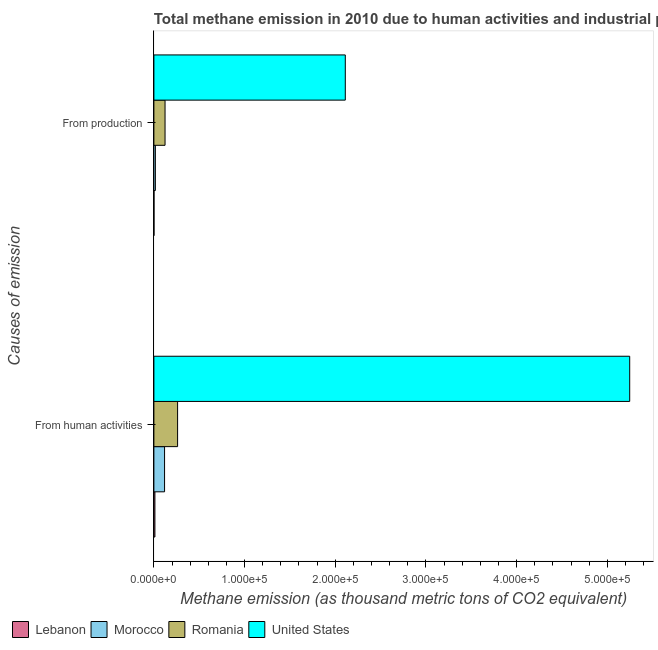Are the number of bars per tick equal to the number of legend labels?
Provide a short and direct response. Yes. How many bars are there on the 2nd tick from the bottom?
Your response must be concise. 4. What is the label of the 2nd group of bars from the top?
Keep it short and to the point. From human activities. What is the amount of emissions generated from industries in Morocco?
Make the answer very short. 1641.9. Across all countries, what is the maximum amount of emissions from human activities?
Your response must be concise. 5.25e+05. Across all countries, what is the minimum amount of emissions generated from industries?
Offer a very short reply. 118.4. In which country was the amount of emissions generated from industries minimum?
Make the answer very short. Lebanon. What is the total amount of emissions generated from industries in the graph?
Keep it short and to the point. 2.25e+05. What is the difference between the amount of emissions generated from industries in United States and that in Romania?
Keep it short and to the point. 1.99e+05. What is the difference between the amount of emissions from human activities in Lebanon and the amount of emissions generated from industries in United States?
Keep it short and to the point. -2.10e+05. What is the average amount of emissions generated from industries per country?
Give a very brief answer. 5.63e+04. What is the difference between the amount of emissions from human activities and amount of emissions generated from industries in Lebanon?
Provide a succinct answer. 1009. What is the ratio of the amount of emissions generated from industries in Romania to that in Morocco?
Your answer should be compact. 7.5. In how many countries, is the amount of emissions generated from industries greater than the average amount of emissions generated from industries taken over all countries?
Keep it short and to the point. 1. What does the 2nd bar from the top in From human activities represents?
Give a very brief answer. Romania. What does the 1st bar from the bottom in From human activities represents?
Make the answer very short. Lebanon. How many countries are there in the graph?
Make the answer very short. 4. What is the difference between two consecutive major ticks on the X-axis?
Provide a short and direct response. 1.00e+05. Are the values on the major ticks of X-axis written in scientific E-notation?
Give a very brief answer. Yes. Does the graph contain grids?
Offer a terse response. No. Where does the legend appear in the graph?
Your response must be concise. Bottom left. How many legend labels are there?
Your response must be concise. 4. What is the title of the graph?
Your answer should be compact. Total methane emission in 2010 due to human activities and industrial production. What is the label or title of the X-axis?
Your answer should be very brief. Methane emission (as thousand metric tons of CO2 equivalent). What is the label or title of the Y-axis?
Keep it short and to the point. Causes of emission. What is the Methane emission (as thousand metric tons of CO2 equivalent) of Lebanon in From human activities?
Your answer should be very brief. 1127.4. What is the Methane emission (as thousand metric tons of CO2 equivalent) in Morocco in From human activities?
Keep it short and to the point. 1.18e+04. What is the Methane emission (as thousand metric tons of CO2 equivalent) of Romania in From human activities?
Your answer should be compact. 2.61e+04. What is the Methane emission (as thousand metric tons of CO2 equivalent) of United States in From human activities?
Keep it short and to the point. 5.25e+05. What is the Methane emission (as thousand metric tons of CO2 equivalent) in Lebanon in From production?
Provide a short and direct response. 118.4. What is the Methane emission (as thousand metric tons of CO2 equivalent) in Morocco in From production?
Your answer should be very brief. 1641.9. What is the Methane emission (as thousand metric tons of CO2 equivalent) in Romania in From production?
Ensure brevity in your answer.  1.23e+04. What is the Methane emission (as thousand metric tons of CO2 equivalent) in United States in From production?
Your answer should be compact. 2.11e+05. Across all Causes of emission, what is the maximum Methane emission (as thousand metric tons of CO2 equivalent) of Lebanon?
Provide a succinct answer. 1127.4. Across all Causes of emission, what is the maximum Methane emission (as thousand metric tons of CO2 equivalent) in Morocco?
Offer a very short reply. 1.18e+04. Across all Causes of emission, what is the maximum Methane emission (as thousand metric tons of CO2 equivalent) of Romania?
Your response must be concise. 2.61e+04. Across all Causes of emission, what is the maximum Methane emission (as thousand metric tons of CO2 equivalent) in United States?
Make the answer very short. 5.25e+05. Across all Causes of emission, what is the minimum Methane emission (as thousand metric tons of CO2 equivalent) of Lebanon?
Your answer should be compact. 118.4. Across all Causes of emission, what is the minimum Methane emission (as thousand metric tons of CO2 equivalent) in Morocco?
Ensure brevity in your answer.  1641.9. Across all Causes of emission, what is the minimum Methane emission (as thousand metric tons of CO2 equivalent) of Romania?
Make the answer very short. 1.23e+04. Across all Causes of emission, what is the minimum Methane emission (as thousand metric tons of CO2 equivalent) of United States?
Your response must be concise. 2.11e+05. What is the total Methane emission (as thousand metric tons of CO2 equivalent) of Lebanon in the graph?
Your answer should be very brief. 1245.8. What is the total Methane emission (as thousand metric tons of CO2 equivalent) of Morocco in the graph?
Your response must be concise. 1.34e+04. What is the total Methane emission (as thousand metric tons of CO2 equivalent) in Romania in the graph?
Provide a succinct answer. 3.85e+04. What is the total Methane emission (as thousand metric tons of CO2 equivalent) of United States in the graph?
Keep it short and to the point. 7.36e+05. What is the difference between the Methane emission (as thousand metric tons of CO2 equivalent) in Lebanon in From human activities and that in From production?
Offer a terse response. 1009. What is the difference between the Methane emission (as thousand metric tons of CO2 equivalent) in Morocco in From human activities and that in From production?
Make the answer very short. 1.01e+04. What is the difference between the Methane emission (as thousand metric tons of CO2 equivalent) in Romania in From human activities and that in From production?
Your answer should be very brief. 1.38e+04. What is the difference between the Methane emission (as thousand metric tons of CO2 equivalent) of United States in From human activities and that in From production?
Your answer should be very brief. 3.14e+05. What is the difference between the Methane emission (as thousand metric tons of CO2 equivalent) in Lebanon in From human activities and the Methane emission (as thousand metric tons of CO2 equivalent) in Morocco in From production?
Ensure brevity in your answer.  -514.5. What is the difference between the Methane emission (as thousand metric tons of CO2 equivalent) of Lebanon in From human activities and the Methane emission (as thousand metric tons of CO2 equivalent) of Romania in From production?
Make the answer very short. -1.12e+04. What is the difference between the Methane emission (as thousand metric tons of CO2 equivalent) in Lebanon in From human activities and the Methane emission (as thousand metric tons of CO2 equivalent) in United States in From production?
Keep it short and to the point. -2.10e+05. What is the difference between the Methane emission (as thousand metric tons of CO2 equivalent) of Morocco in From human activities and the Methane emission (as thousand metric tons of CO2 equivalent) of Romania in From production?
Your answer should be compact. -538. What is the difference between the Methane emission (as thousand metric tons of CO2 equivalent) in Morocco in From human activities and the Methane emission (as thousand metric tons of CO2 equivalent) in United States in From production?
Make the answer very short. -1.99e+05. What is the difference between the Methane emission (as thousand metric tons of CO2 equivalent) of Romania in From human activities and the Methane emission (as thousand metric tons of CO2 equivalent) of United States in From production?
Give a very brief answer. -1.85e+05. What is the average Methane emission (as thousand metric tons of CO2 equivalent) in Lebanon per Causes of emission?
Your answer should be very brief. 622.9. What is the average Methane emission (as thousand metric tons of CO2 equivalent) of Morocco per Causes of emission?
Offer a very short reply. 6709.75. What is the average Methane emission (as thousand metric tons of CO2 equivalent) of Romania per Causes of emission?
Offer a very short reply. 1.92e+04. What is the average Methane emission (as thousand metric tons of CO2 equivalent) of United States per Causes of emission?
Give a very brief answer. 3.68e+05. What is the difference between the Methane emission (as thousand metric tons of CO2 equivalent) of Lebanon and Methane emission (as thousand metric tons of CO2 equivalent) of Morocco in From human activities?
Make the answer very short. -1.07e+04. What is the difference between the Methane emission (as thousand metric tons of CO2 equivalent) in Lebanon and Methane emission (as thousand metric tons of CO2 equivalent) in Romania in From human activities?
Keep it short and to the point. -2.50e+04. What is the difference between the Methane emission (as thousand metric tons of CO2 equivalent) of Lebanon and Methane emission (as thousand metric tons of CO2 equivalent) of United States in From human activities?
Your answer should be compact. -5.24e+05. What is the difference between the Methane emission (as thousand metric tons of CO2 equivalent) in Morocco and Methane emission (as thousand metric tons of CO2 equivalent) in Romania in From human activities?
Ensure brevity in your answer.  -1.44e+04. What is the difference between the Methane emission (as thousand metric tons of CO2 equivalent) in Morocco and Methane emission (as thousand metric tons of CO2 equivalent) in United States in From human activities?
Offer a very short reply. -5.13e+05. What is the difference between the Methane emission (as thousand metric tons of CO2 equivalent) of Romania and Methane emission (as thousand metric tons of CO2 equivalent) of United States in From human activities?
Provide a short and direct response. -4.99e+05. What is the difference between the Methane emission (as thousand metric tons of CO2 equivalent) in Lebanon and Methane emission (as thousand metric tons of CO2 equivalent) in Morocco in From production?
Your answer should be very brief. -1523.5. What is the difference between the Methane emission (as thousand metric tons of CO2 equivalent) of Lebanon and Methane emission (as thousand metric tons of CO2 equivalent) of Romania in From production?
Make the answer very short. -1.22e+04. What is the difference between the Methane emission (as thousand metric tons of CO2 equivalent) of Lebanon and Methane emission (as thousand metric tons of CO2 equivalent) of United States in From production?
Keep it short and to the point. -2.11e+05. What is the difference between the Methane emission (as thousand metric tons of CO2 equivalent) of Morocco and Methane emission (as thousand metric tons of CO2 equivalent) of Romania in From production?
Offer a very short reply. -1.07e+04. What is the difference between the Methane emission (as thousand metric tons of CO2 equivalent) in Morocco and Methane emission (as thousand metric tons of CO2 equivalent) in United States in From production?
Offer a very short reply. -2.09e+05. What is the difference between the Methane emission (as thousand metric tons of CO2 equivalent) of Romania and Methane emission (as thousand metric tons of CO2 equivalent) of United States in From production?
Your response must be concise. -1.99e+05. What is the ratio of the Methane emission (as thousand metric tons of CO2 equivalent) of Lebanon in From human activities to that in From production?
Ensure brevity in your answer.  9.52. What is the ratio of the Methane emission (as thousand metric tons of CO2 equivalent) in Morocco in From human activities to that in From production?
Keep it short and to the point. 7.17. What is the ratio of the Methane emission (as thousand metric tons of CO2 equivalent) of Romania in From human activities to that in From production?
Your answer should be very brief. 2.12. What is the ratio of the Methane emission (as thousand metric tons of CO2 equivalent) in United States in From human activities to that in From production?
Ensure brevity in your answer.  2.49. What is the difference between the highest and the second highest Methane emission (as thousand metric tons of CO2 equivalent) of Lebanon?
Ensure brevity in your answer.  1009. What is the difference between the highest and the second highest Methane emission (as thousand metric tons of CO2 equivalent) in Morocco?
Ensure brevity in your answer.  1.01e+04. What is the difference between the highest and the second highest Methane emission (as thousand metric tons of CO2 equivalent) in Romania?
Make the answer very short. 1.38e+04. What is the difference between the highest and the second highest Methane emission (as thousand metric tons of CO2 equivalent) in United States?
Provide a short and direct response. 3.14e+05. What is the difference between the highest and the lowest Methane emission (as thousand metric tons of CO2 equivalent) of Lebanon?
Offer a very short reply. 1009. What is the difference between the highest and the lowest Methane emission (as thousand metric tons of CO2 equivalent) of Morocco?
Give a very brief answer. 1.01e+04. What is the difference between the highest and the lowest Methane emission (as thousand metric tons of CO2 equivalent) of Romania?
Provide a short and direct response. 1.38e+04. What is the difference between the highest and the lowest Methane emission (as thousand metric tons of CO2 equivalent) of United States?
Provide a succinct answer. 3.14e+05. 